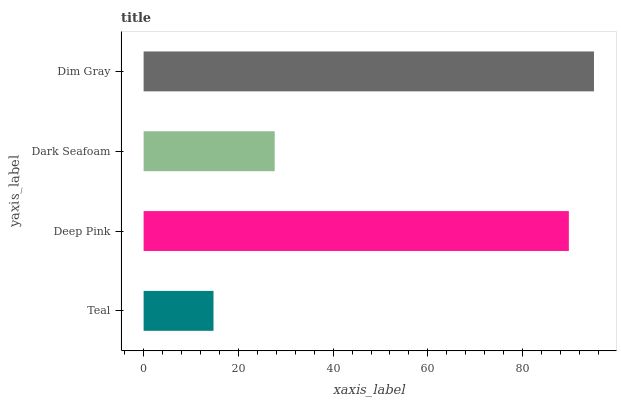Is Teal the minimum?
Answer yes or no. Yes. Is Dim Gray the maximum?
Answer yes or no. Yes. Is Deep Pink the minimum?
Answer yes or no. No. Is Deep Pink the maximum?
Answer yes or no. No. Is Deep Pink greater than Teal?
Answer yes or no. Yes. Is Teal less than Deep Pink?
Answer yes or no. Yes. Is Teal greater than Deep Pink?
Answer yes or no. No. Is Deep Pink less than Teal?
Answer yes or no. No. Is Deep Pink the high median?
Answer yes or no. Yes. Is Dark Seafoam the low median?
Answer yes or no. Yes. Is Dim Gray the high median?
Answer yes or no. No. Is Dim Gray the low median?
Answer yes or no. No. 